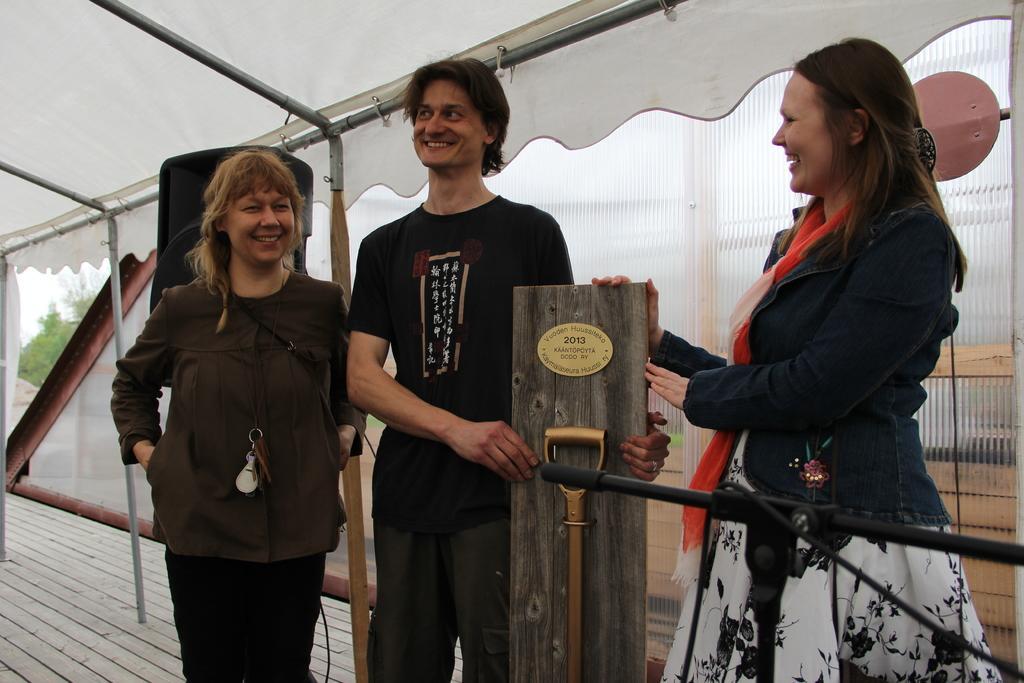Can you describe this image briefly? In this image we can see a man and a lady standing and holding a wood board, next to them there is another lady. In the background there is a tent and we can see a stand. 